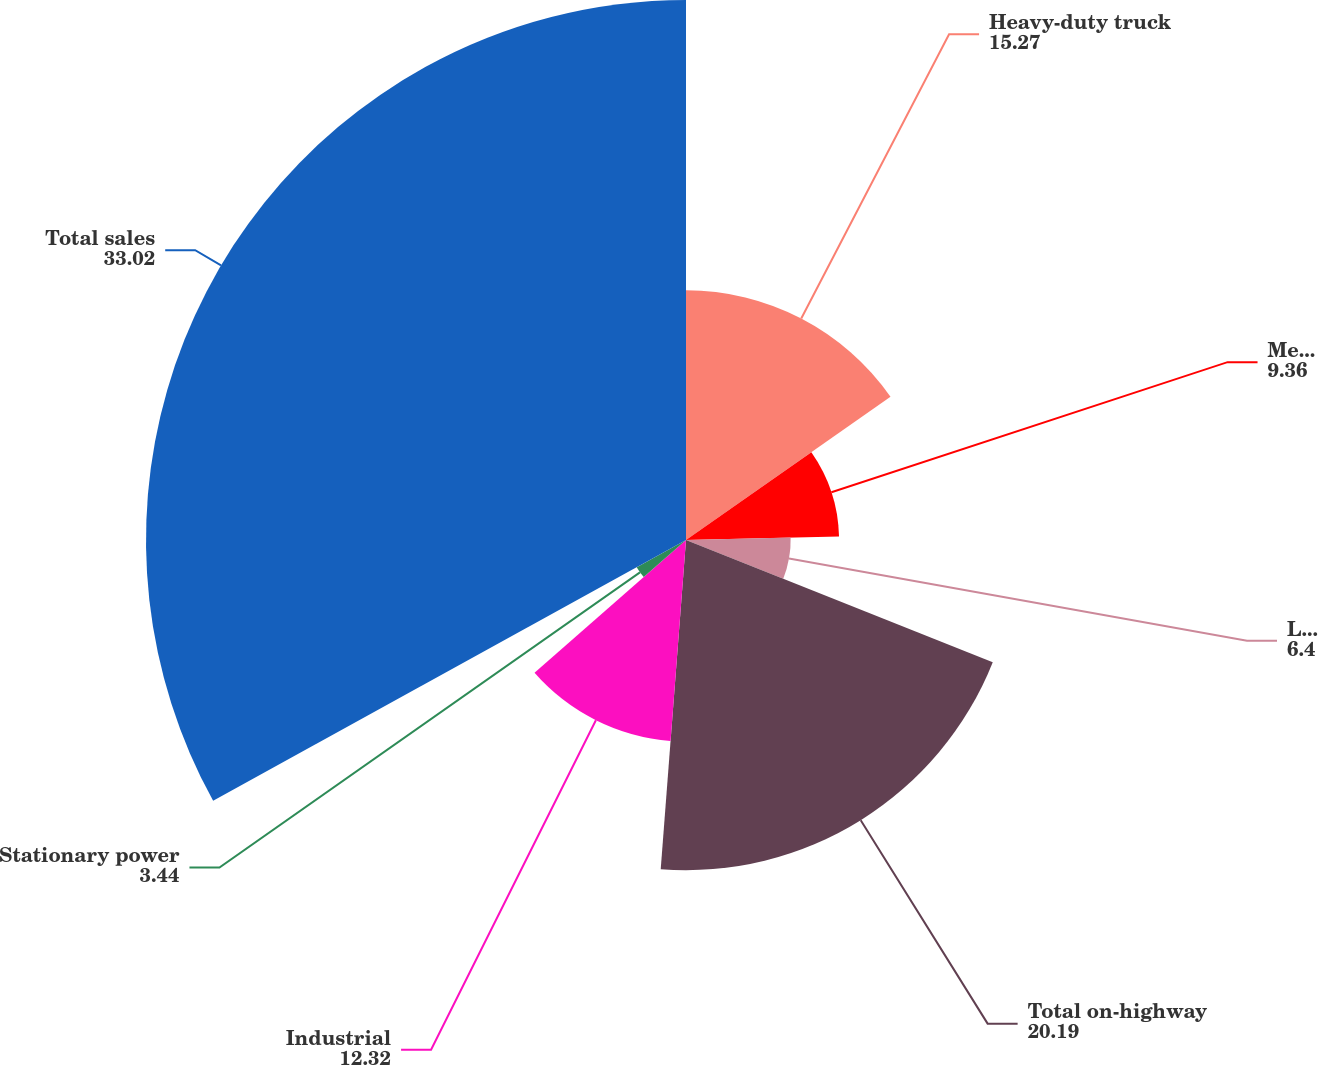Convert chart. <chart><loc_0><loc_0><loc_500><loc_500><pie_chart><fcel>Heavy-duty truck<fcel>Medium-duty truck and bus<fcel>Light-duty automotive and RV<fcel>Total on-highway<fcel>Industrial<fcel>Stationary power<fcel>Total sales<nl><fcel>15.27%<fcel>9.36%<fcel>6.4%<fcel>20.19%<fcel>12.32%<fcel>3.44%<fcel>33.02%<nl></chart> 